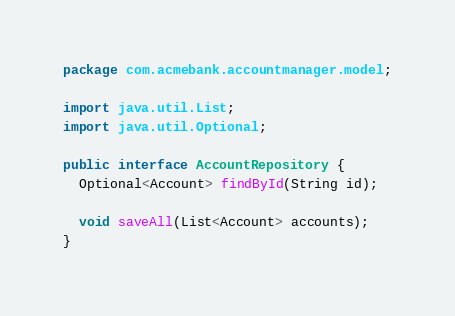Convert code to text. <code><loc_0><loc_0><loc_500><loc_500><_Java_>package com.acmebank.accountmanager.model;

import java.util.List;
import java.util.Optional;

public interface AccountRepository {
  Optional<Account> findById(String id);

  void saveAll(List<Account> accounts);
}
</code> 